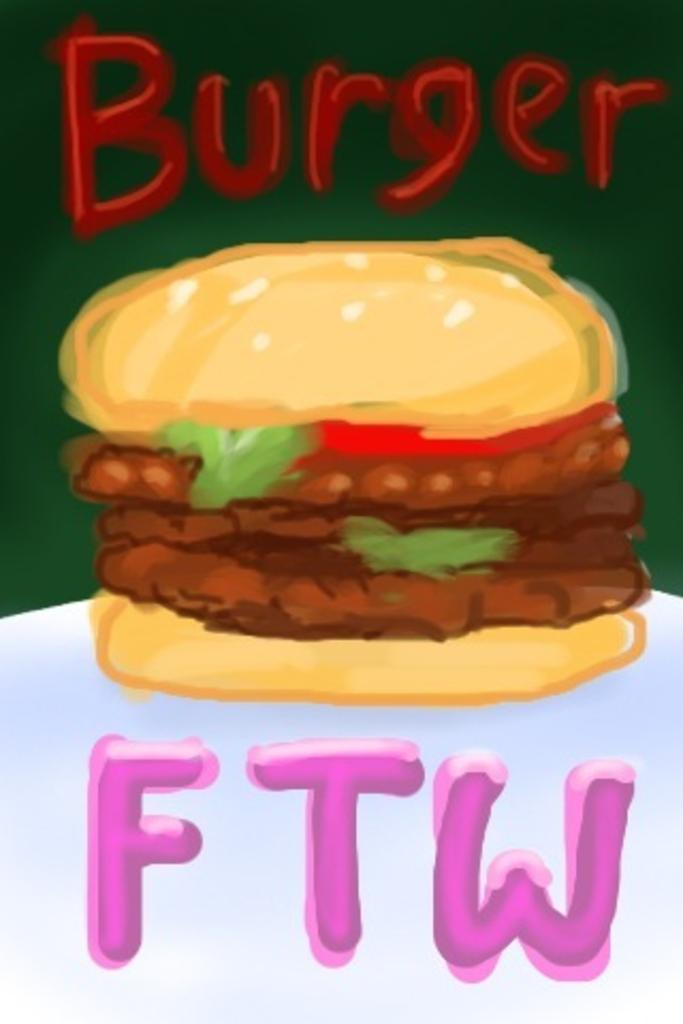What is the main subject of the painting in the image? The main subject of the painting in the image is a burger. Where is the painting located in the image? The painting of the burger is in the middle of the image. What else can be seen in the image besides the painting? There is text at the top and bottom of the image. How does the kitten feel about the burger in the image? There is no kitten present in the image, so it is not possible to determine how a kitten might feel about the burger. 